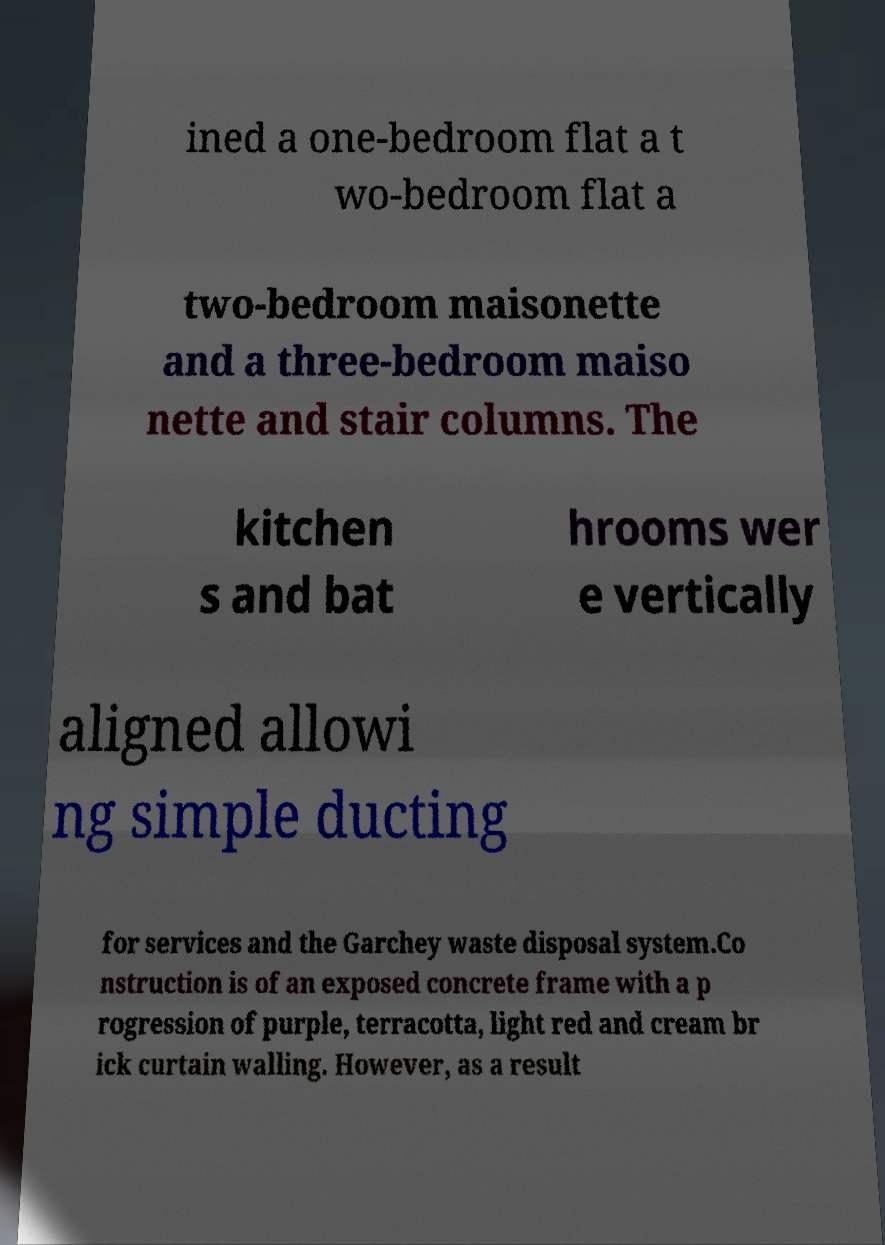There's text embedded in this image that I need extracted. Can you transcribe it verbatim? ined a one-bedroom flat a t wo-bedroom flat a two-bedroom maisonette and a three-bedroom maiso nette and stair columns. The kitchen s and bat hrooms wer e vertically aligned allowi ng simple ducting for services and the Garchey waste disposal system.Co nstruction is of an exposed concrete frame with a p rogression of purple, terracotta, light red and cream br ick curtain walling. However, as a result 